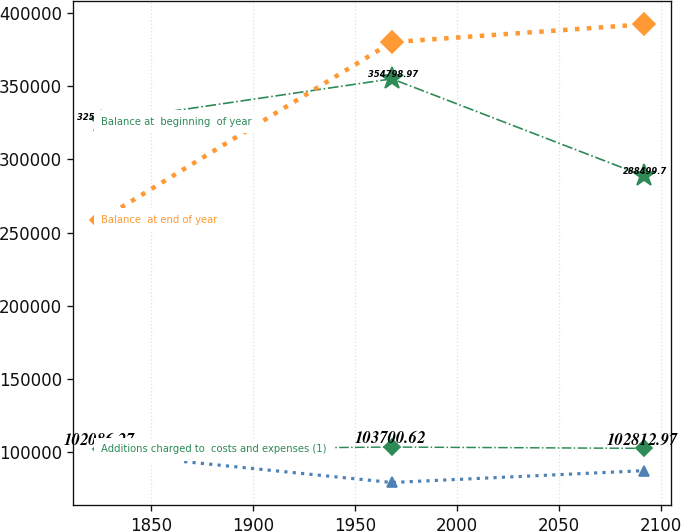Convert chart. <chart><loc_0><loc_0><loc_500><loc_500><line_chart><ecel><fcel>Deductions (2)<fcel>Balance at  beginning  of year<fcel>Balance  at end of year<fcel>Additions charged to  costs and expenses (1)<nl><fcel>1825.43<fcel>99491.7<fcel>325612<fcel>258582<fcel>102086<nl><fcel>1968.24<fcel>79536.7<fcel>354799<fcel>379808<fcel>103701<nl><fcel>2091.91<fcel>87618<fcel>288500<fcel>391964<fcel>102813<nl></chart> 